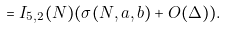<formula> <loc_0><loc_0><loc_500><loc_500>= I _ { 5 , 2 } ( N ) ( \sigma ( N , a , b ) + O ( \Delta ) ) .</formula> 